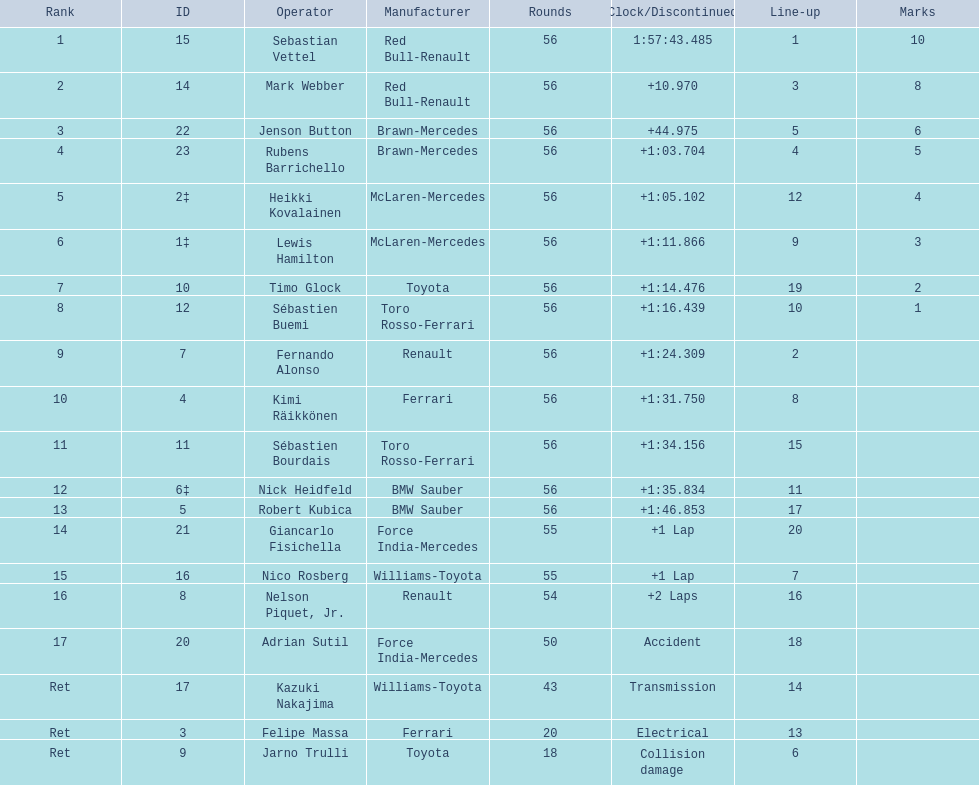Who were all of the drivers in the 2009 chinese grand prix? Sebastian Vettel, Mark Webber, Jenson Button, Rubens Barrichello, Heikki Kovalainen, Lewis Hamilton, Timo Glock, Sébastien Buemi, Fernando Alonso, Kimi Räikkönen, Sébastien Bourdais, Nick Heidfeld, Robert Kubica, Giancarlo Fisichella, Nico Rosberg, Nelson Piquet, Jr., Adrian Sutil, Kazuki Nakajima, Felipe Massa, Jarno Trulli. And what were their finishing times? 1:57:43.485, +10.970, +44.975, +1:03.704, +1:05.102, +1:11.866, +1:14.476, +1:16.439, +1:24.309, +1:31.750, +1:34.156, +1:35.834, +1:46.853, +1 Lap, +1 Lap, +2 Laps, Accident, Transmission, Electrical, Collision damage. Which player faced collision damage and retired from the race? Jarno Trulli. 